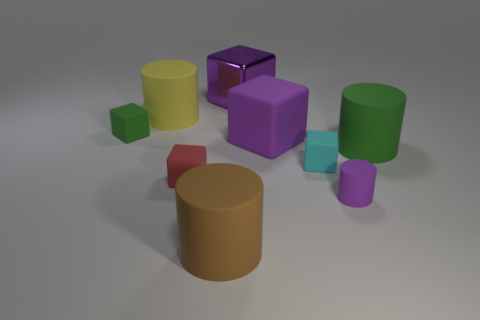Can you describe the arrangement of the cylinders and the cube in the image? The image displays a collection of geometric shapes positioned on a flat surface. In the center, there is a large brown cylinder with a red cylinder on its left and a smaller purple cylinder in front of it. To the right, a green cylinder stands prominently, along with a yellow one behind it. Additionally, a purple cube with a peculiar reflective surface captures the eye as it rests among the cylinders. 